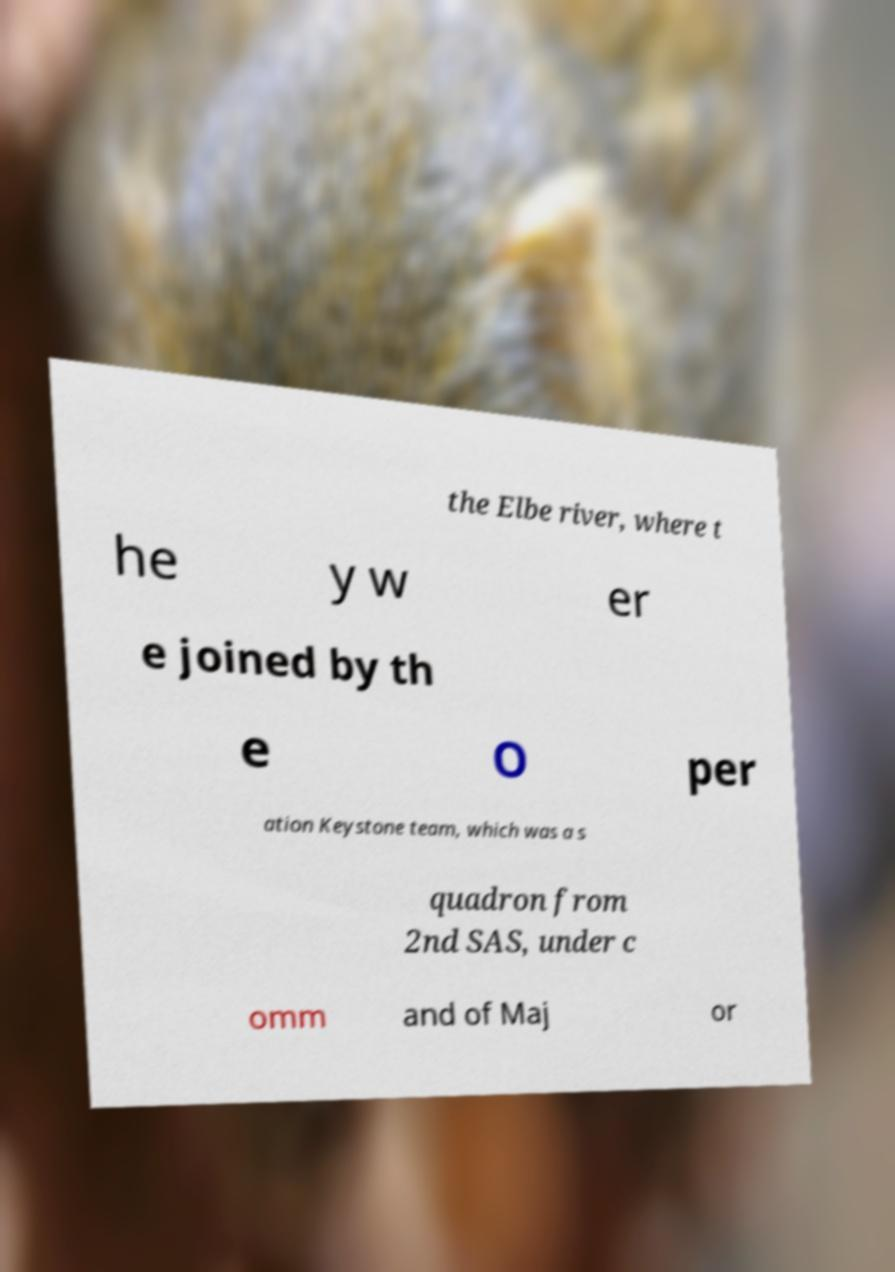Can you accurately transcribe the text from the provided image for me? the Elbe river, where t he y w er e joined by th e O per ation Keystone team, which was a s quadron from 2nd SAS, under c omm and of Maj or 